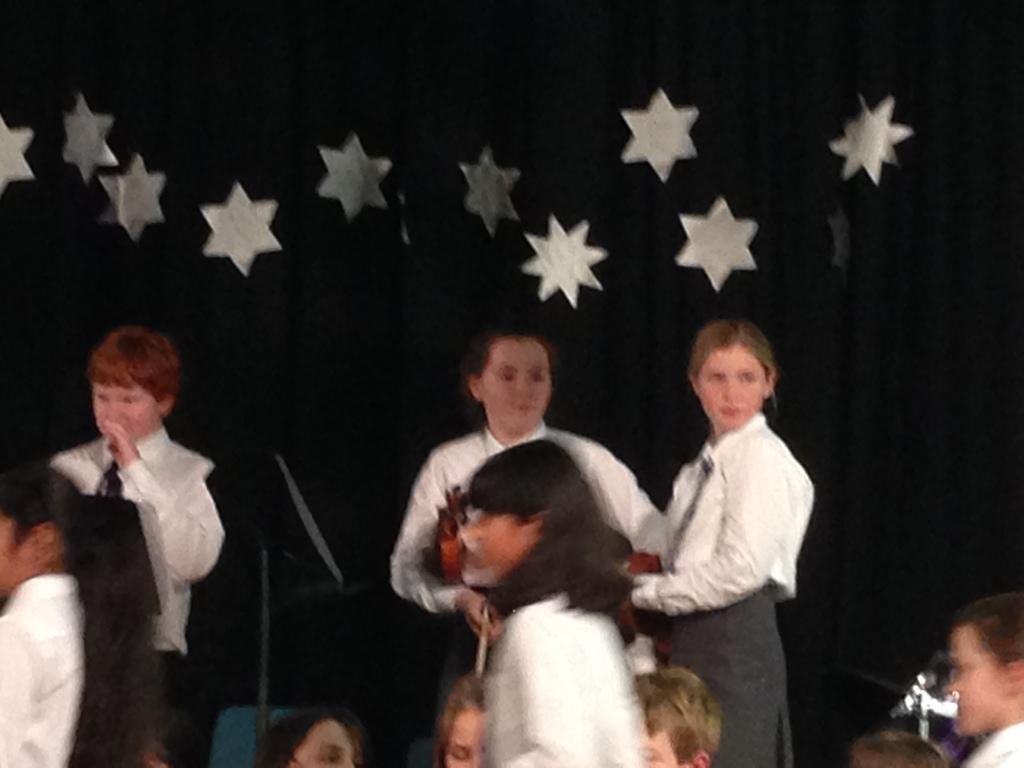Could you give a brief overview of what you see in this image? In this image we can see a few people. They are wearing a white color shirt and a tie. In the background, we can see the black color cloth with stars on it. 